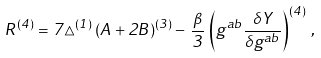Convert formula to latex. <formula><loc_0><loc_0><loc_500><loc_500>R ^ { ( 4 ) } = 7 \triangle ^ { ( 1 ) } \, ( A + 2 B ) ^ { ( 3 ) } - \, \frac { \beta } { 3 } \, \left ( g ^ { a b } \frac { \delta Y } { \delta g ^ { a b } } \right ) ^ { ( 4 ) } \, ,</formula> 